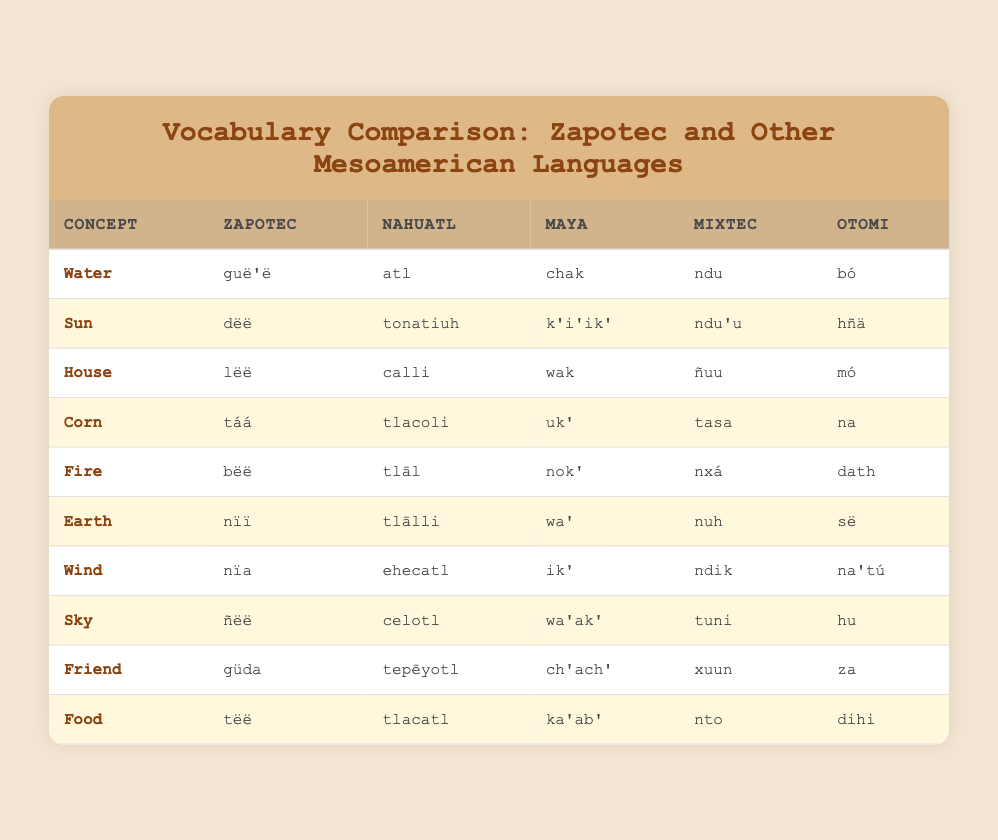What is the Zapotec word for "Fire"? The table shows the concept "Fire" along with its translation in various languages. The Zapotec word corresponding to "Fire" is listed as "bëë".
Answer: bëë Which Mesoamerican language uses the word "atl" for "Water"? According to the table, the word "atl" corresponds to the concept "Water". It is listed under the Nahuatl column, indicating that Nahuatl uses this word for "Water".
Answer: Nahuatl What are the translations for "Earth" in both Zapotec and Mixtec? From the table, we look at the concept "Earth". The Zapotec translation is "nïï" and the Mixtec translation is "nuh".
Answer: nïï (Zapotec), nuh (Mixtec) Is the word for "Sky" the same in Zapotec and Maya? The table lists the word for "Sky" in both Zapotec ("ñëë") and Maya ("wa'ak'"). Since they are different, the answer is no.
Answer: No Which concept has the same translation in Nahuatl and Mixtec? We examine the table for identical translations under the columns for Nahuatl and Mixtec. The concept "Corn" has Nahuatl as "tlacoli" and Mixtec as "tasa", while "House" has Nahuatl "calli" and Mixtec "ñuu". All translations are distinct. Therefore, no concept shares the same translation.
Answer: None What is the difference between the Zapotec and Otomi words for "Friend"? From the table, "Friend" is translated as "güda" in Zapotec and "za" in Otomi. The difference between the two words lies in their phonetic structure and specific cultural implications but does not quantify numerically since these are linguistic terms.
Answer: güda (Zapotec), za (Otomi) Count the total unique translations listed for the concept "Food". The table lists "Food" translated into all languages. The translations are "tëë" (Zapotec), "tlacatl" (Nahuatl), "ka'ab'" (Maya), "nto" (Mixtec), and "dihi" (Otomi), giving us a total of 5 unique translations.
Answer: 5 Which word appears most frequently across the different languages for elements of nature? By inspecting the table, we look for words corresponding to natural elements like "Water," "Fire," "Earth," "Wind," "Sky," and "Corn". Each concept is uniquely translated across all languages without repetition of a single word. Therefore, none of the words appears more than once.
Answer: None Which Mesoamerican language has the word "hñä" corresponding to the concept "Sun"? Referring to the table, the word "hñä" corresponds to "Sun" under the Otomi language.
Answer: Otomi What is the average length of the Zapotec words listed in the table? Calculating the lengths: "guë'ë" (5), "dëë" (3), "lëë" (3), "táá" (3), "bëë" (3), "nïï" (3), "nïa" (3), "ñëë" (4), "güda" (4), "tëë" (3). The total length is 34 and there are 10 words, so the average is 34/10 = 3.4.
Answer: 3.4 